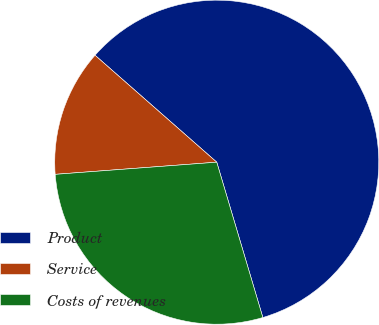<chart> <loc_0><loc_0><loc_500><loc_500><pie_chart><fcel>Product<fcel>Service<fcel>Costs of revenues<nl><fcel>58.94%<fcel>12.67%<fcel>28.4%<nl></chart> 